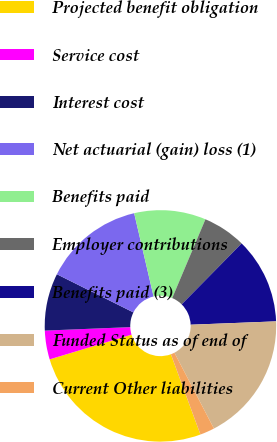<chart> <loc_0><loc_0><loc_500><loc_500><pie_chart><fcel>Projected benefit obligation<fcel>Service cost<fcel>Interest cost<fcel>Net actuarial (gain) loss (1)<fcel>Benefits paid<fcel>Employer contributions<fcel>Benefits paid (3)<fcel>Funded Status as of end of<fcel>Current Other liabilities<nl><fcel>25.95%<fcel>4.02%<fcel>8.01%<fcel>13.99%<fcel>10.0%<fcel>6.02%<fcel>12.0%<fcel>17.98%<fcel>2.03%<nl></chart> 